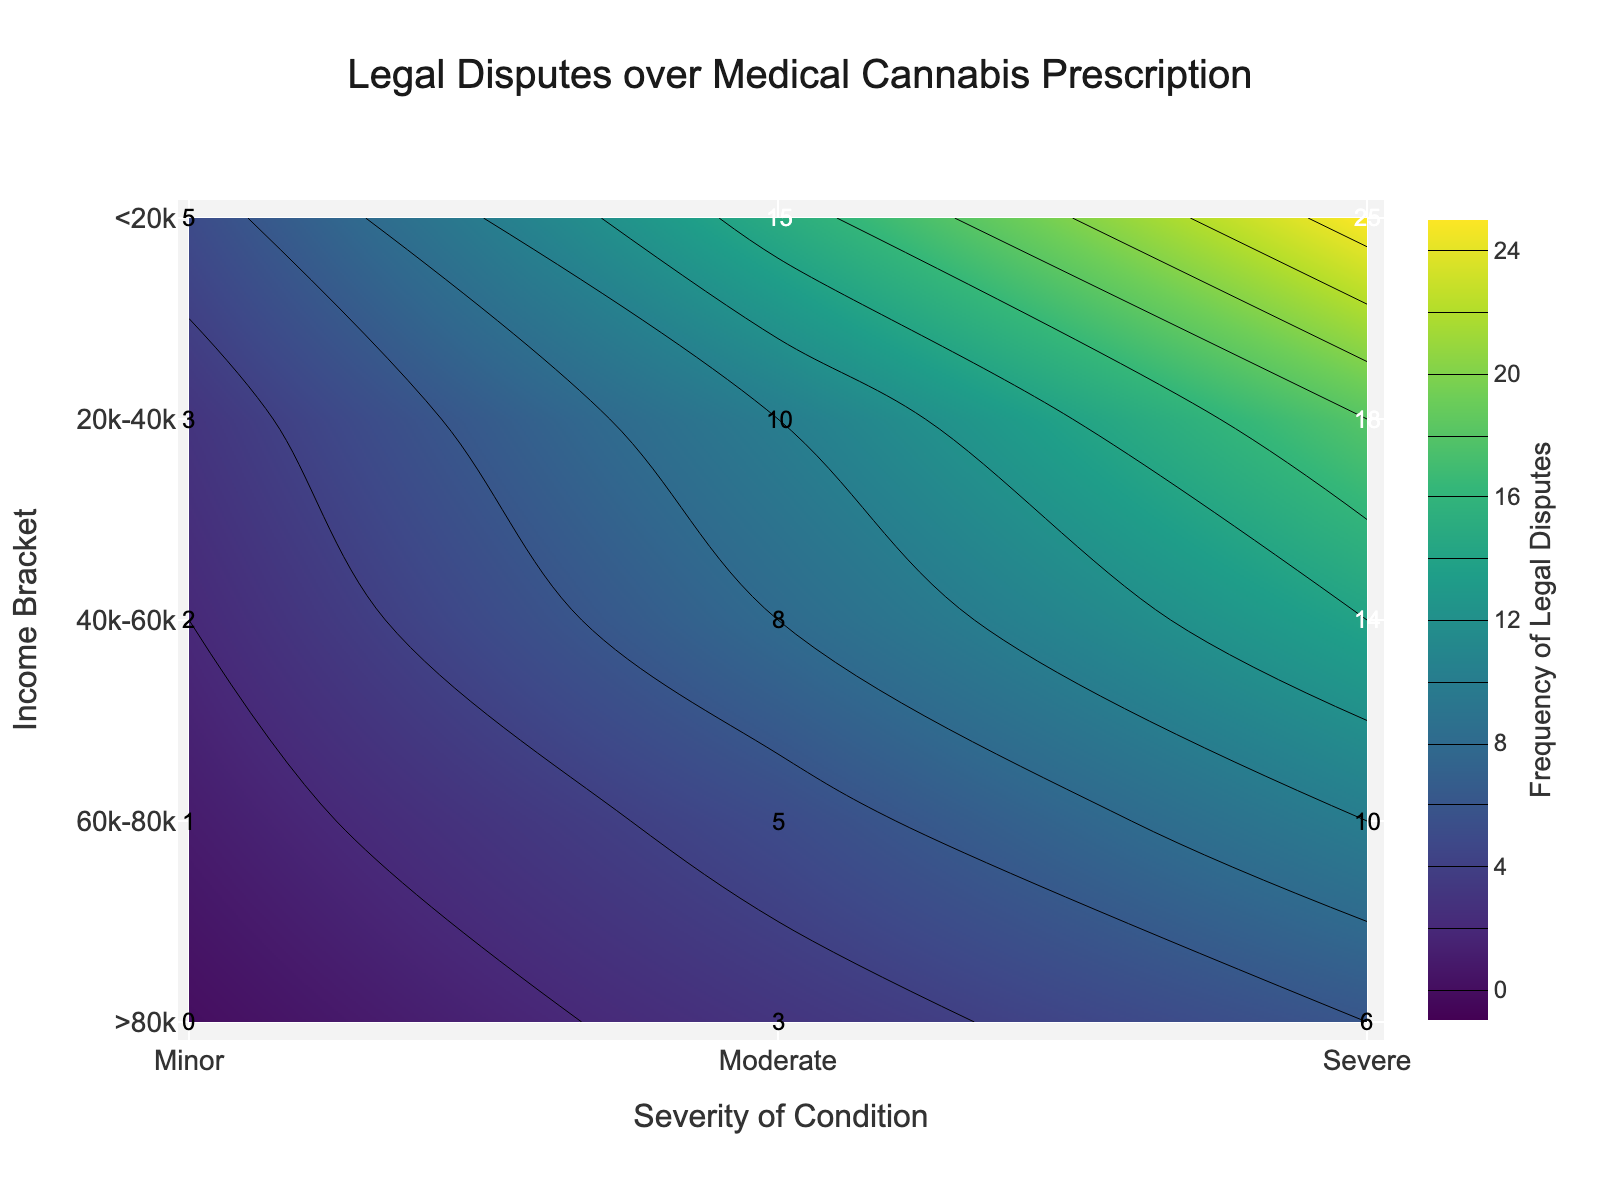What is the title of the plot? The title is displayed at the top center of the plot, which helps to understand what the plot is about.
Answer: Legal Disputes over Medical Cannabis Prescription What does the color scale represent? The color scale represents the frequency of legal disputes over medical cannabis prescriptions, from lower to higher values.
Answer: Frequency of Legal Disputes Which axis represents the severity of the condition? The x-axis represents the severity of the condition, labeled with 'Minor', 'Moderate', and 'Severe'.
Answer: x-axis Which income bracket has the highest frequency of legal disputes for severe conditions? Looking at the 'Severe' column, the first income bracket '<20k' has the highest value (25).
Answer: <20k What is the frequency of legal disputes for the income bracket 40k-60k with moderate severity? Refer to the intersection of '40k-60k' row and the 'Moderate' column, the value is 8.
Answer: 8 How many income brackets have zero frequency for any severity level? Check each row for zeros in the frequency values. Only the '>80k' bracket has zero for 'Minor' severity.
Answer: 1 What is the difference in the frequency of legal disputes between the moderate and severe conditions for the 20k-40k income bracket? Find the values for 'Moderate' (10) and 'Severe' (18), and compute the difference: 18 - 10 = 8.
Answer: 8 Which severity level generally shows the lowest frequency of legal disputes across all income brackets? Compare the columns, 'Minor' generally shows the lowest values such as 5, 3, 2, 1, and 0.
Answer: Minor Which income bracket shows the biggest drop-off in frequency of legal disputes when moving from moderate to severe conditions? Calculate the differences: 
<20k: 25 - 15 = 10, 
20k-40k: 18 - 10 = 8, 
40k-60k: 14 - 8 = 6, 
60k-80k: 10 - 5 = 5, 
>80k: 6 - 3 = 3. 
The largest drop is 10 for the <20k bracket.
Answer: <20k Which severity level sees the smallest variation in legal dispute frequency across all income brackets? Compute the range (max - min) for each severity level:
Minor: 5 - 0 = 5,
Moderate: 15 - 3 = 12,
Severe: 25 - 6 = 19.
Minor has the smallest variation.
Answer: Minor 